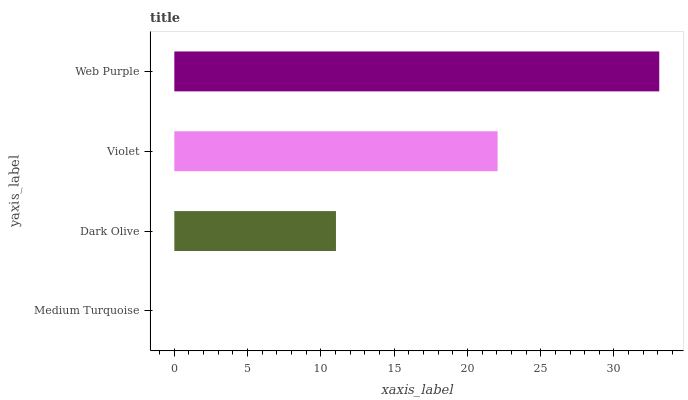Is Medium Turquoise the minimum?
Answer yes or no. Yes. Is Web Purple the maximum?
Answer yes or no. Yes. Is Dark Olive the minimum?
Answer yes or no. No. Is Dark Olive the maximum?
Answer yes or no. No. Is Dark Olive greater than Medium Turquoise?
Answer yes or no. Yes. Is Medium Turquoise less than Dark Olive?
Answer yes or no. Yes. Is Medium Turquoise greater than Dark Olive?
Answer yes or no. No. Is Dark Olive less than Medium Turquoise?
Answer yes or no. No. Is Violet the high median?
Answer yes or no. Yes. Is Dark Olive the low median?
Answer yes or no. Yes. Is Dark Olive the high median?
Answer yes or no. No. Is Medium Turquoise the low median?
Answer yes or no. No. 